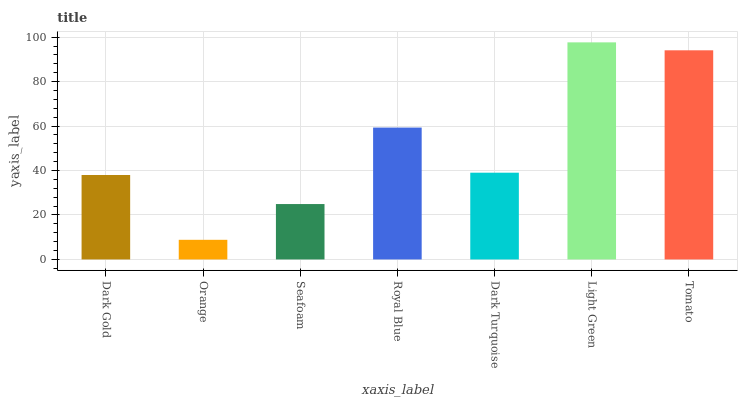Is Seafoam the minimum?
Answer yes or no. No. Is Seafoam the maximum?
Answer yes or no. No. Is Seafoam greater than Orange?
Answer yes or no. Yes. Is Orange less than Seafoam?
Answer yes or no. Yes. Is Orange greater than Seafoam?
Answer yes or no. No. Is Seafoam less than Orange?
Answer yes or no. No. Is Dark Turquoise the high median?
Answer yes or no. Yes. Is Dark Turquoise the low median?
Answer yes or no. Yes. Is Light Green the high median?
Answer yes or no. No. Is Dark Gold the low median?
Answer yes or no. No. 